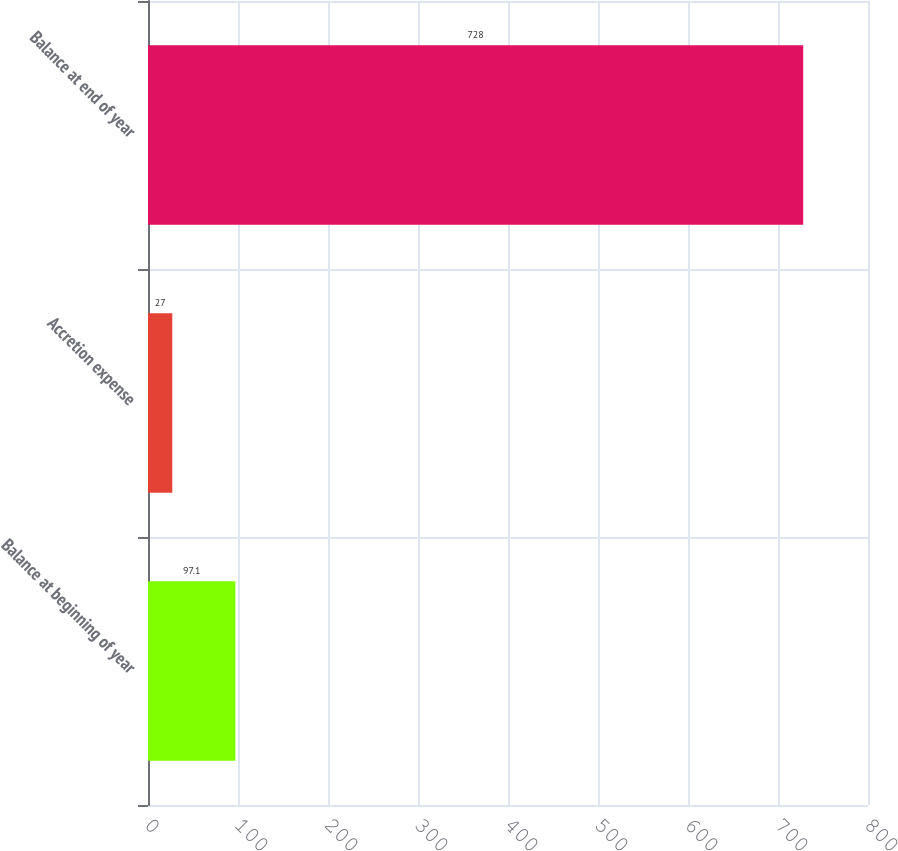Convert chart. <chart><loc_0><loc_0><loc_500><loc_500><bar_chart><fcel>Balance at beginning of year<fcel>Accretion expense<fcel>Balance at end of year<nl><fcel>97.1<fcel>27<fcel>728<nl></chart> 